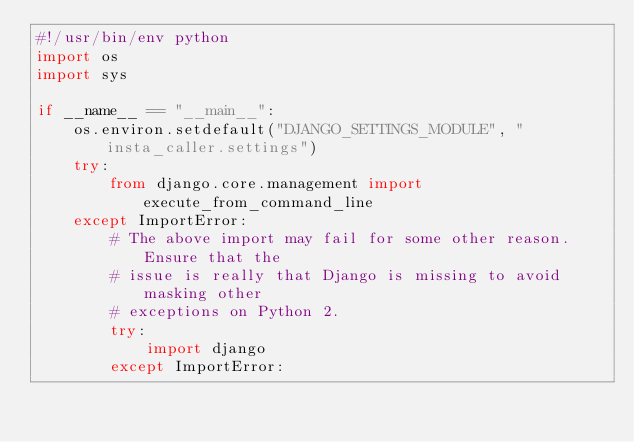Convert code to text. <code><loc_0><loc_0><loc_500><loc_500><_Python_>#!/usr/bin/env python
import os
import sys

if __name__ == "__main__":
    os.environ.setdefault("DJANGO_SETTINGS_MODULE", "insta_caller.settings")
    try:
        from django.core.management import execute_from_command_line
    except ImportError:
        # The above import may fail for some other reason. Ensure that the
        # issue is really that Django is missing to avoid masking other
        # exceptions on Python 2.
        try:
            import django
        except ImportError:</code> 